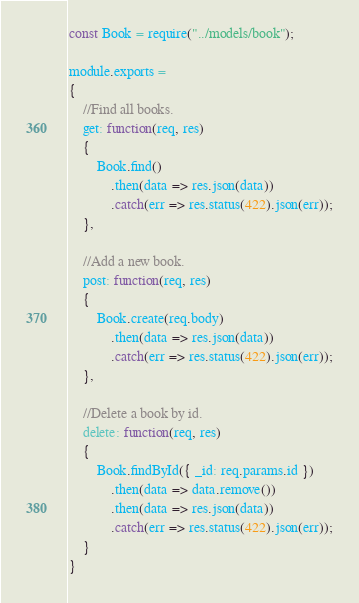<code> <loc_0><loc_0><loc_500><loc_500><_JavaScript_>const Book = require("../models/book");

module.exports =
{
    //Find all books.
    get: function(req, res)
    {
        Book.find()
            .then(data => res.json(data))
            .catch(err => res.status(422).json(err));
    },

    //Add a new book.
    post: function(req, res)
    {
        Book.create(req.body)
            .then(data => res.json(data))
            .catch(err => res.status(422).json(err));
    },

    //Delete a book by id.
    delete: function(req, res)
    {
        Book.findById({ _id: req.params.id })
            .then(data => data.remove())
            .then(data => res.json(data))
            .catch(err => res.status(422).json(err));
    }
}</code> 